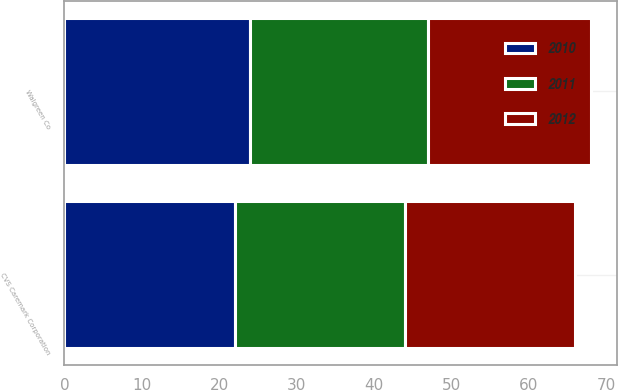<chart> <loc_0><loc_0><loc_500><loc_500><stacked_bar_chart><ecel><fcel>CVS Caremark Corporation<fcel>Walgreen Co<nl><fcel>2012<fcel>22<fcel>21<nl><fcel>2011<fcel>22<fcel>23<nl><fcel>2010<fcel>22<fcel>24<nl></chart> 